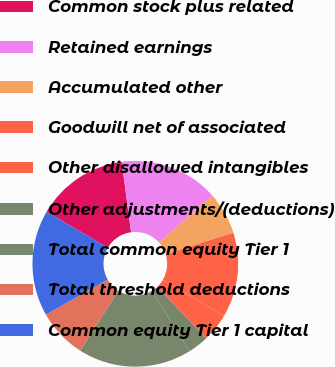Convert chart to OTSL. <chart><loc_0><loc_0><loc_500><loc_500><pie_chart><fcel>Common stock plus related<fcel>Retained earnings<fcel>Accumulated other<fcel>Goodwill net of associated<fcel>Other disallowed intangibles<fcel>Other adjustments/(deductions)<fcel>Total common equity Tier 1<fcel>Total threshold deductions<fcel>Common equity Tier 1 capital<nl><fcel>14.44%<fcel>15.56%<fcel>6.67%<fcel>13.33%<fcel>4.44%<fcel>3.33%<fcel>17.78%<fcel>7.78%<fcel>16.67%<nl></chart> 